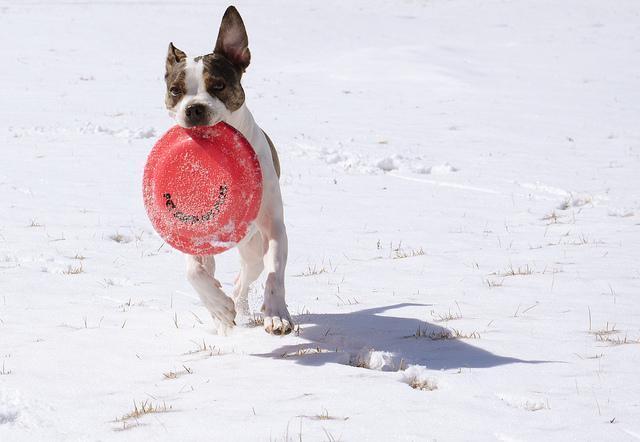How many benches are on the beach?
Give a very brief answer. 0. 